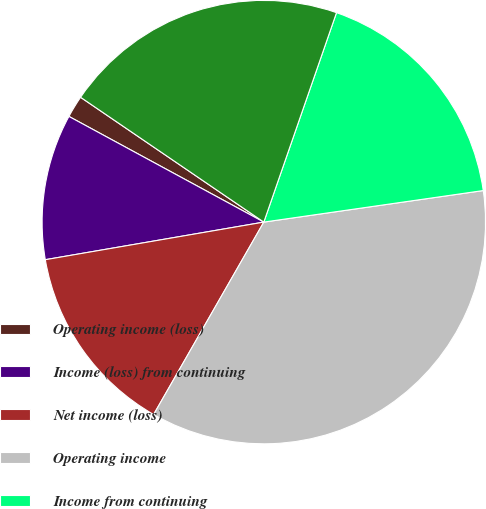Convert chart to OTSL. <chart><loc_0><loc_0><loc_500><loc_500><pie_chart><fcel>Operating income (loss)<fcel>Income (loss) from continuing<fcel>Net income (loss)<fcel>Operating income<fcel>Income from continuing<fcel>Net income<nl><fcel>1.61%<fcel>10.62%<fcel>14.01%<fcel>35.55%<fcel>17.41%<fcel>20.8%<nl></chart> 